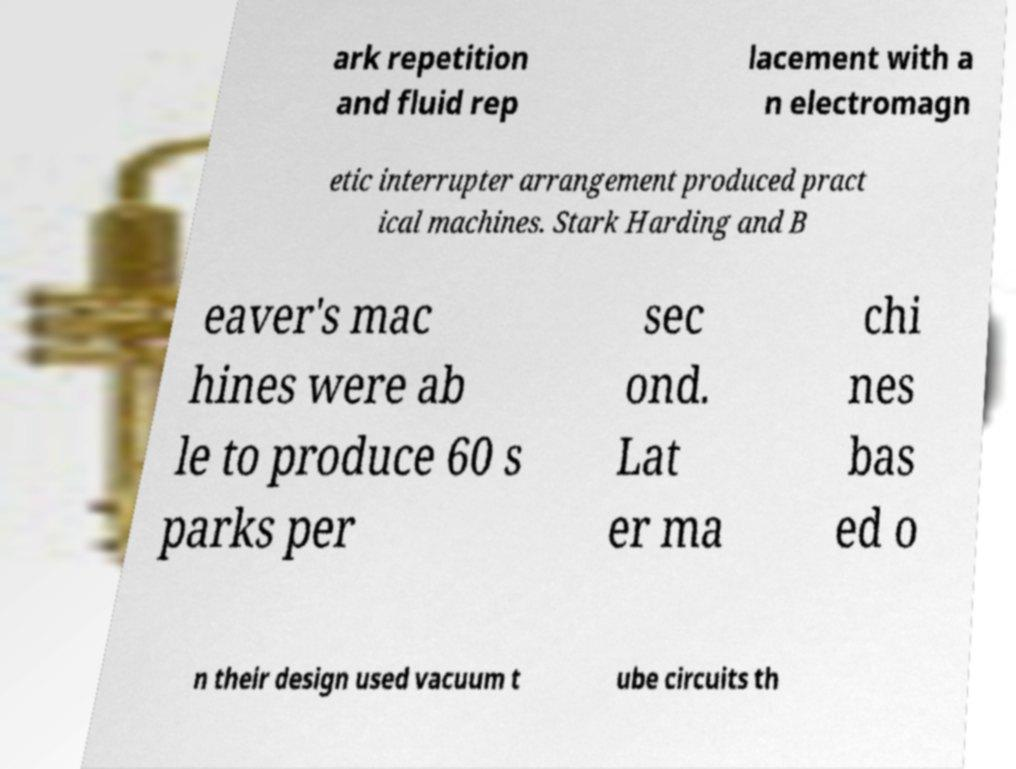Can you read and provide the text displayed in the image?This photo seems to have some interesting text. Can you extract and type it out for me? ark repetition and fluid rep lacement with a n electromagn etic interrupter arrangement produced pract ical machines. Stark Harding and B eaver's mac hines were ab le to produce 60 s parks per sec ond. Lat er ma chi nes bas ed o n their design used vacuum t ube circuits th 